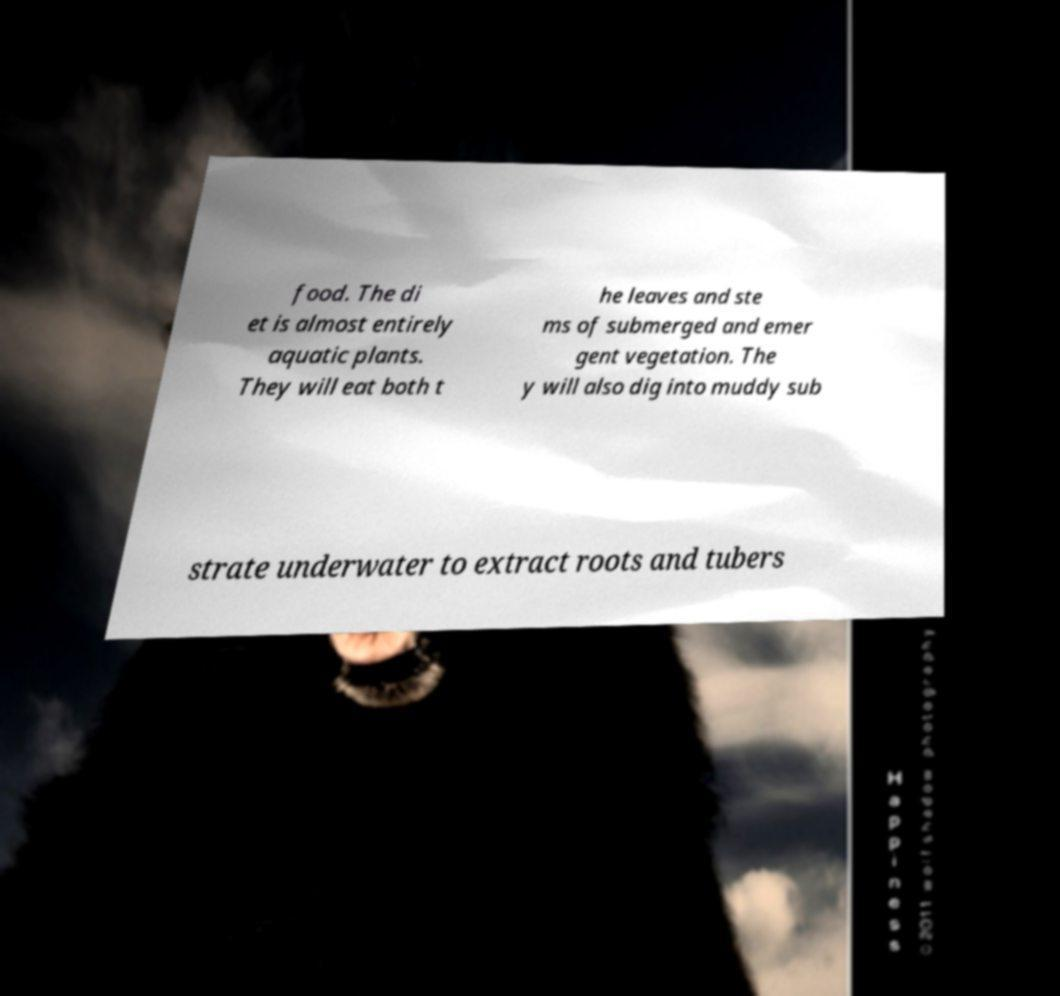Can you read and provide the text displayed in the image?This photo seems to have some interesting text. Can you extract and type it out for me? food. The di et is almost entirely aquatic plants. They will eat both t he leaves and ste ms of submerged and emer gent vegetation. The y will also dig into muddy sub strate underwater to extract roots and tubers 